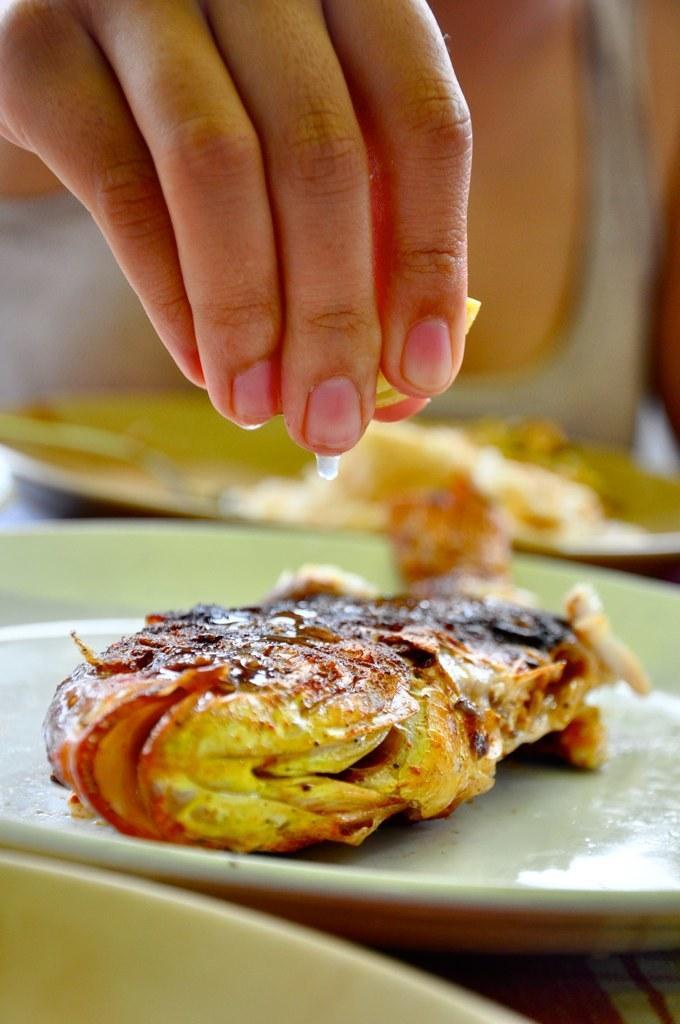Describe this image in one or two sentences. In this image in the foreground there is one plate,in that plate there is some food and in the background there is one woman who is holding a lemon and squeezing and also there is one plate. In that plate there is some food, at the bottom there is another plate. 